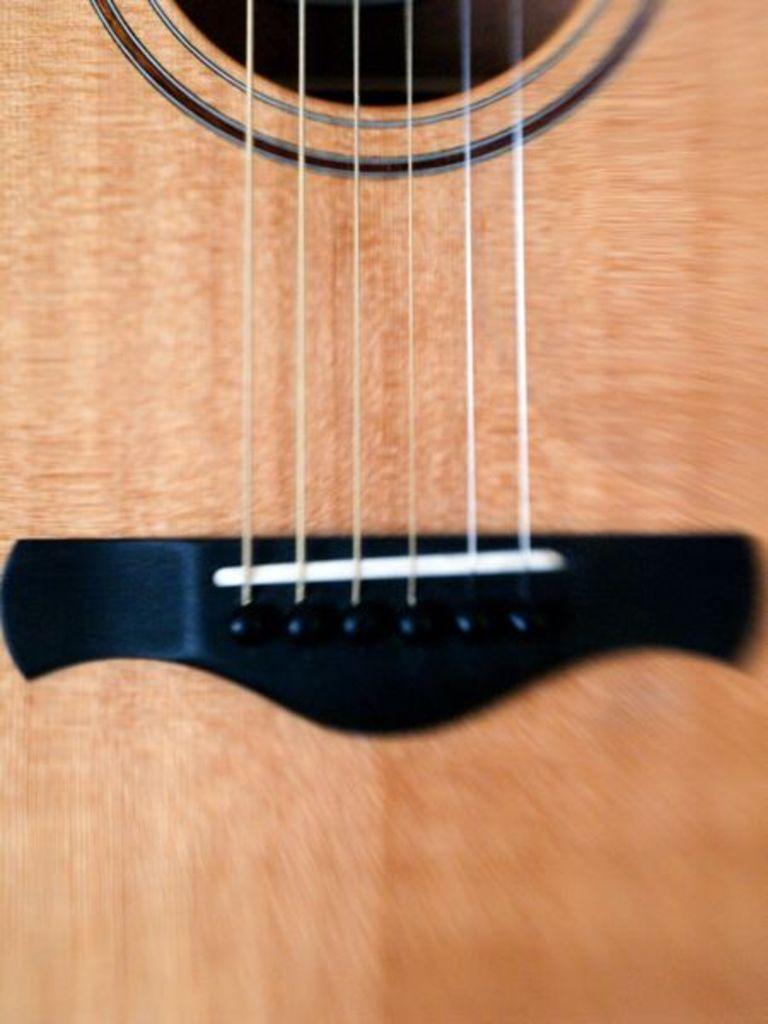Describe this image in one or two sentences. In this image there is guitar where there is a saddle in which there are some bridge pins attached to it then there are 6 strings attached to those bridge pins and this is called as sound whole. 